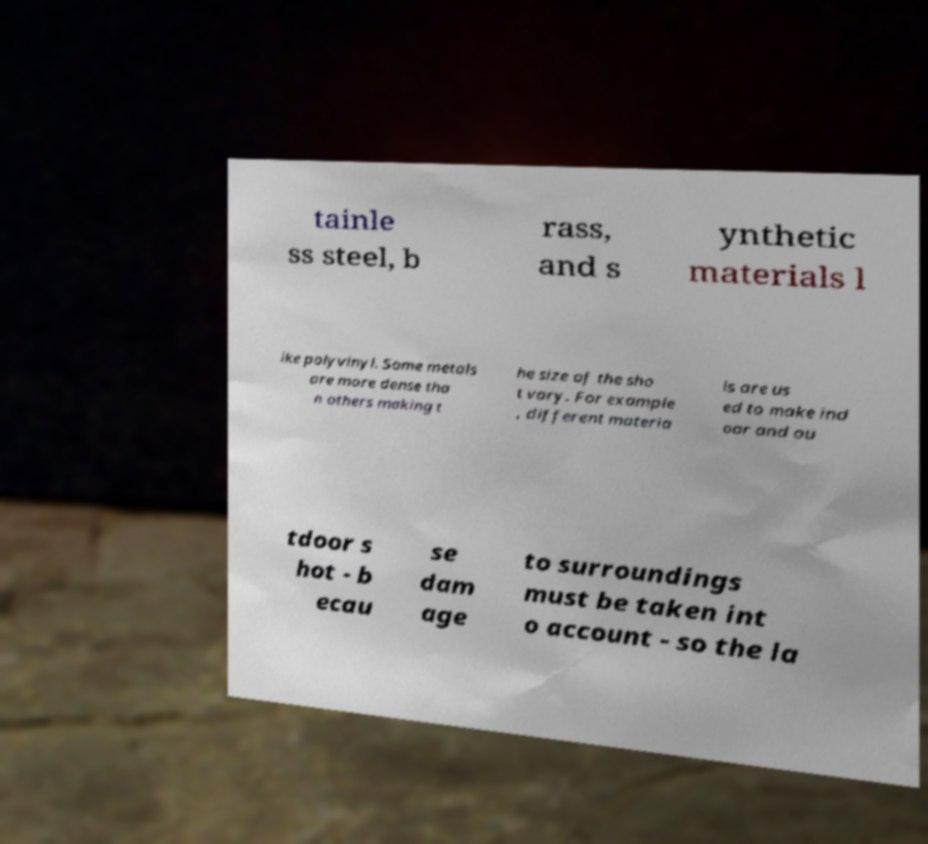Can you read and provide the text displayed in the image?This photo seems to have some interesting text. Can you extract and type it out for me? tainle ss steel, b rass, and s ynthetic materials l ike polyvinyl. Some metals are more dense tha n others making t he size of the sho t vary. For example , different materia ls are us ed to make ind oor and ou tdoor s hot - b ecau se dam age to surroundings must be taken int o account - so the la 